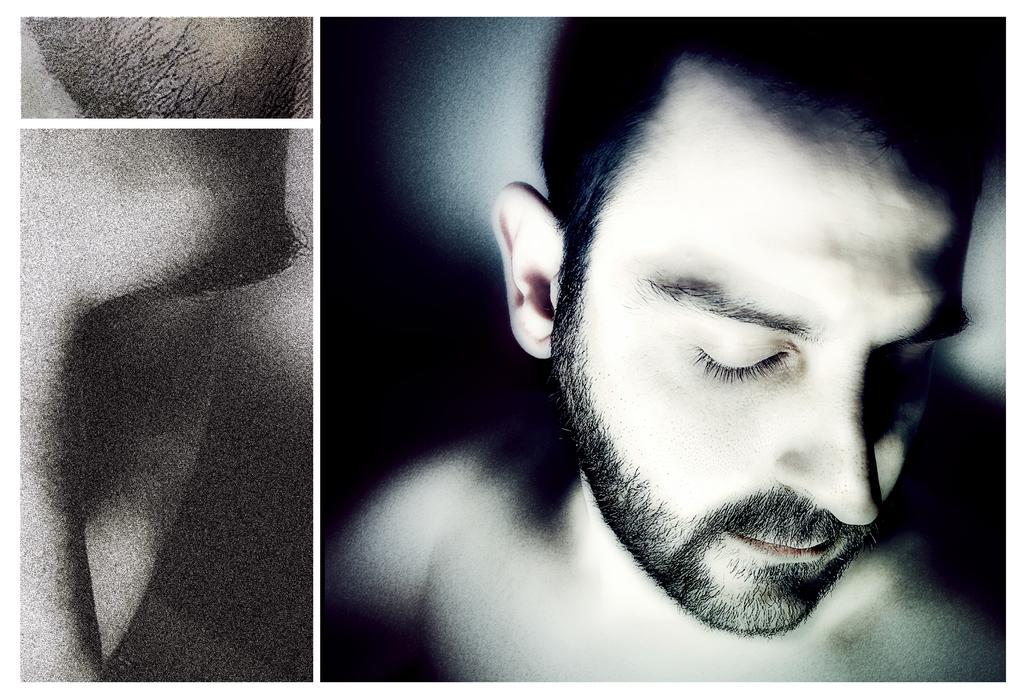What type of image is being described? The image is a collage. What can be found within the collage? There is a picture of a man in the collage. Can you describe a specific part of the collage? The left side of the image appears to depict the eyebrow of the man. What type of laborer is depicted in the image? There is no laborer depicted in the image; it features a collage with a picture of a man. How does the man in the image relate to the other elements in the collage? The provided facts do not give information about the man's relation to other elements in the collage. 